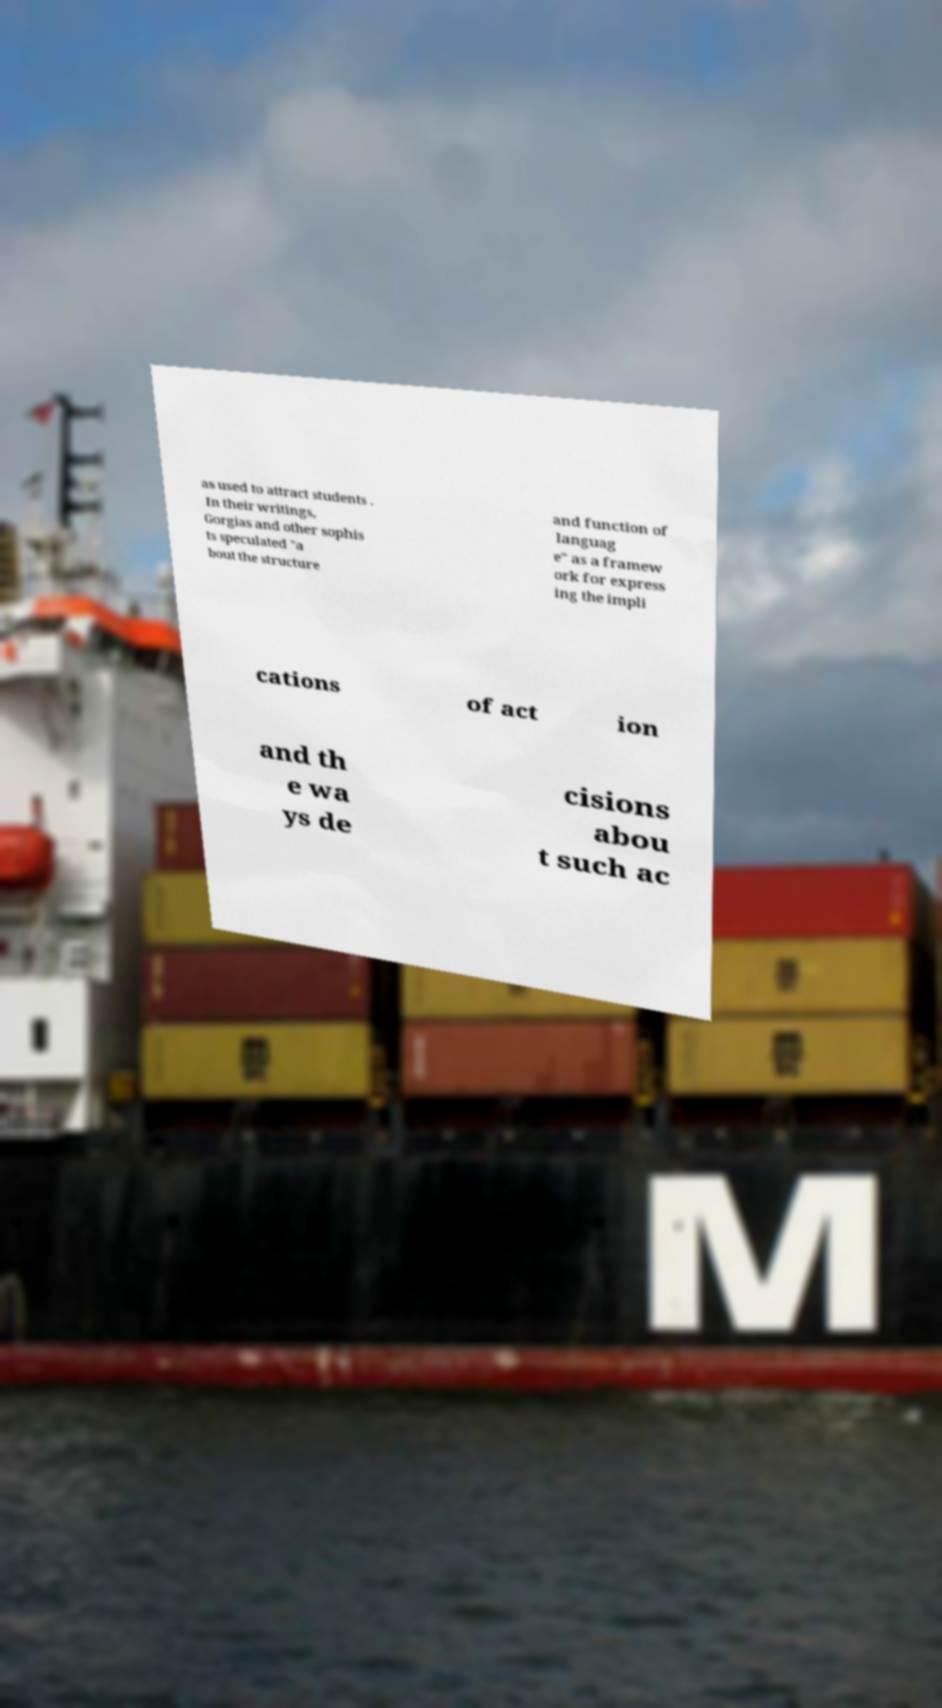I need the written content from this picture converted into text. Can you do that? as used to attract students . In their writings, Gorgias and other sophis ts speculated "a bout the structure and function of languag e" as a framew ork for express ing the impli cations of act ion and th e wa ys de cisions abou t such ac 